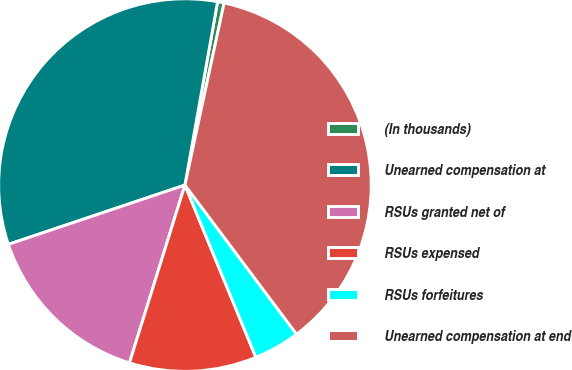Convert chart. <chart><loc_0><loc_0><loc_500><loc_500><pie_chart><fcel>(In thousands)<fcel>Unearned compensation at<fcel>RSUs granted net of<fcel>RSUs expensed<fcel>RSUs forfeitures<fcel>Unearned compensation at end<nl><fcel>0.57%<fcel>32.96%<fcel>15.03%<fcel>11.03%<fcel>4.01%<fcel>36.4%<nl></chart> 